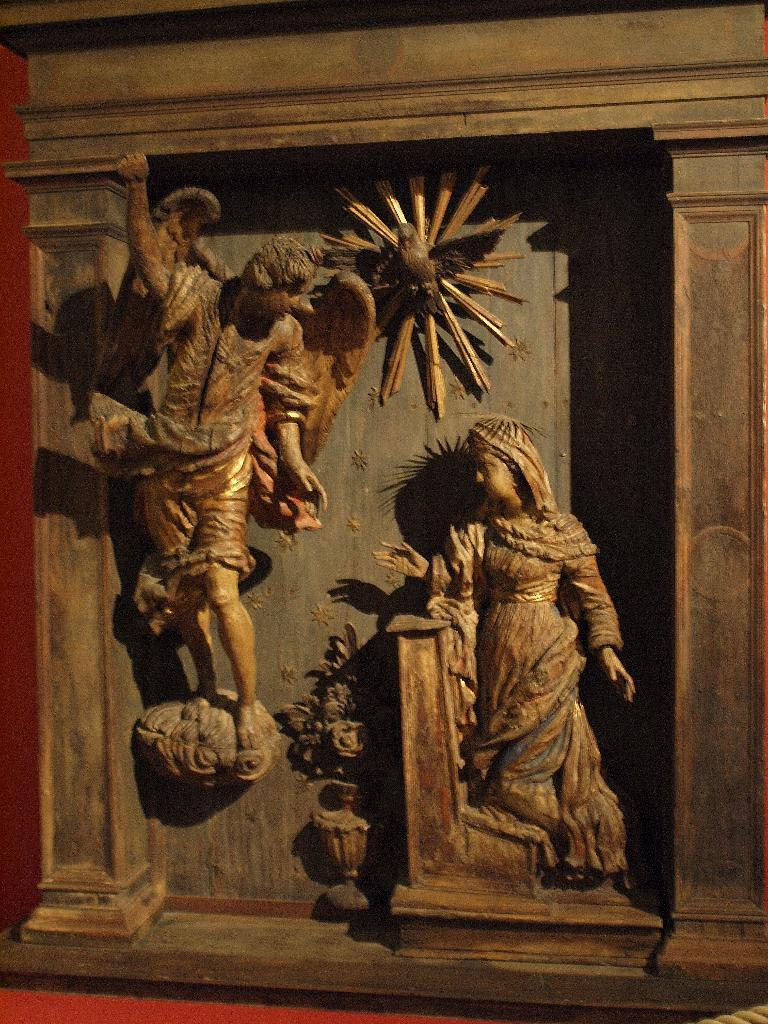What is depicted on the wall in the image? There are sculptures on a wall in the image. What color are the sculptures? The sculptures are brown in color. Can you describe the color of another wall in the image? There is a red color wall in the image. Is there a spy hiding behind the sculptures in the image? There is no indication of a spy or any hidden figure in the image; it only shows sculptures on a wall. 